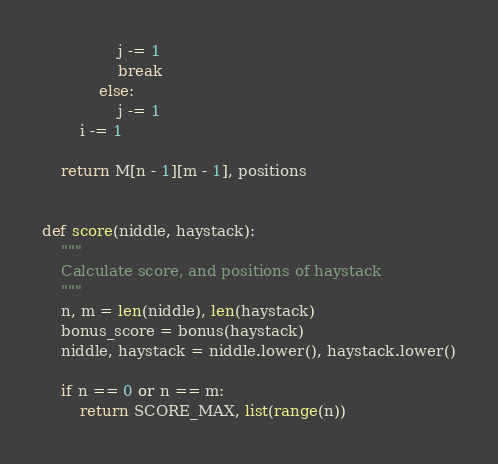Convert code to text. <code><loc_0><loc_0><loc_500><loc_500><_Python_>                j -= 1
                break
            else:
                j -= 1
        i -= 1

    return M[n - 1][m - 1], positions


def score(niddle, haystack):
    """
    Calculate score, and positions of haystack
    """
    n, m = len(niddle), len(haystack)
    bonus_score = bonus(haystack)
    niddle, haystack = niddle.lower(), haystack.lower()

    if n == 0 or n == m:
        return SCORE_MAX, list(range(n))</code> 